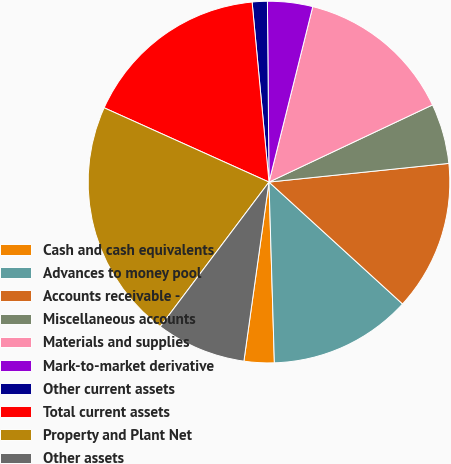Convert chart to OTSL. <chart><loc_0><loc_0><loc_500><loc_500><pie_chart><fcel>Cash and cash equivalents<fcel>Advances to money pool<fcel>Accounts receivable -<fcel>Miscellaneous accounts<fcel>Materials and supplies<fcel>Mark-to-market derivative<fcel>Other current assets<fcel>Total current assets<fcel>Property and Plant Net<fcel>Other assets<nl><fcel>2.69%<fcel>12.75%<fcel>13.42%<fcel>5.37%<fcel>14.09%<fcel>4.03%<fcel>1.35%<fcel>16.77%<fcel>21.47%<fcel>8.05%<nl></chart> 